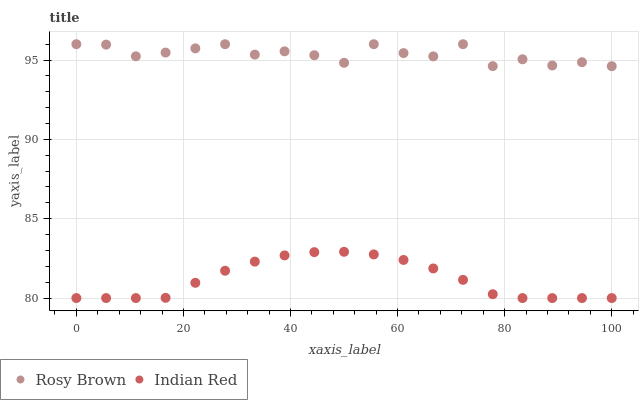Does Indian Red have the minimum area under the curve?
Answer yes or no. Yes. Does Rosy Brown have the maximum area under the curve?
Answer yes or no. Yes. Does Indian Red have the maximum area under the curve?
Answer yes or no. No. Is Indian Red the smoothest?
Answer yes or no. Yes. Is Rosy Brown the roughest?
Answer yes or no. Yes. Is Indian Red the roughest?
Answer yes or no. No. Does Indian Red have the lowest value?
Answer yes or no. Yes. Does Rosy Brown have the highest value?
Answer yes or no. Yes. Does Indian Red have the highest value?
Answer yes or no. No. Is Indian Red less than Rosy Brown?
Answer yes or no. Yes. Is Rosy Brown greater than Indian Red?
Answer yes or no. Yes. Does Indian Red intersect Rosy Brown?
Answer yes or no. No. 